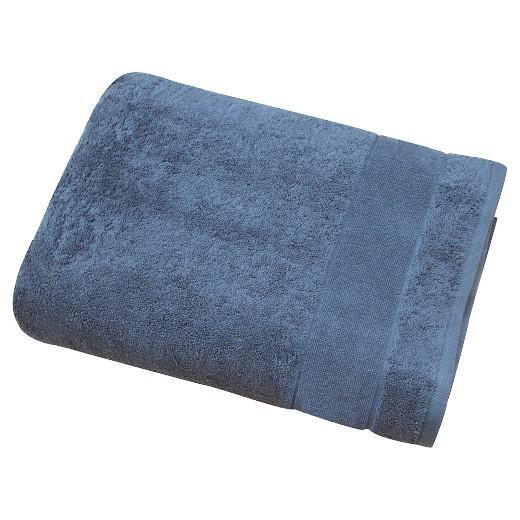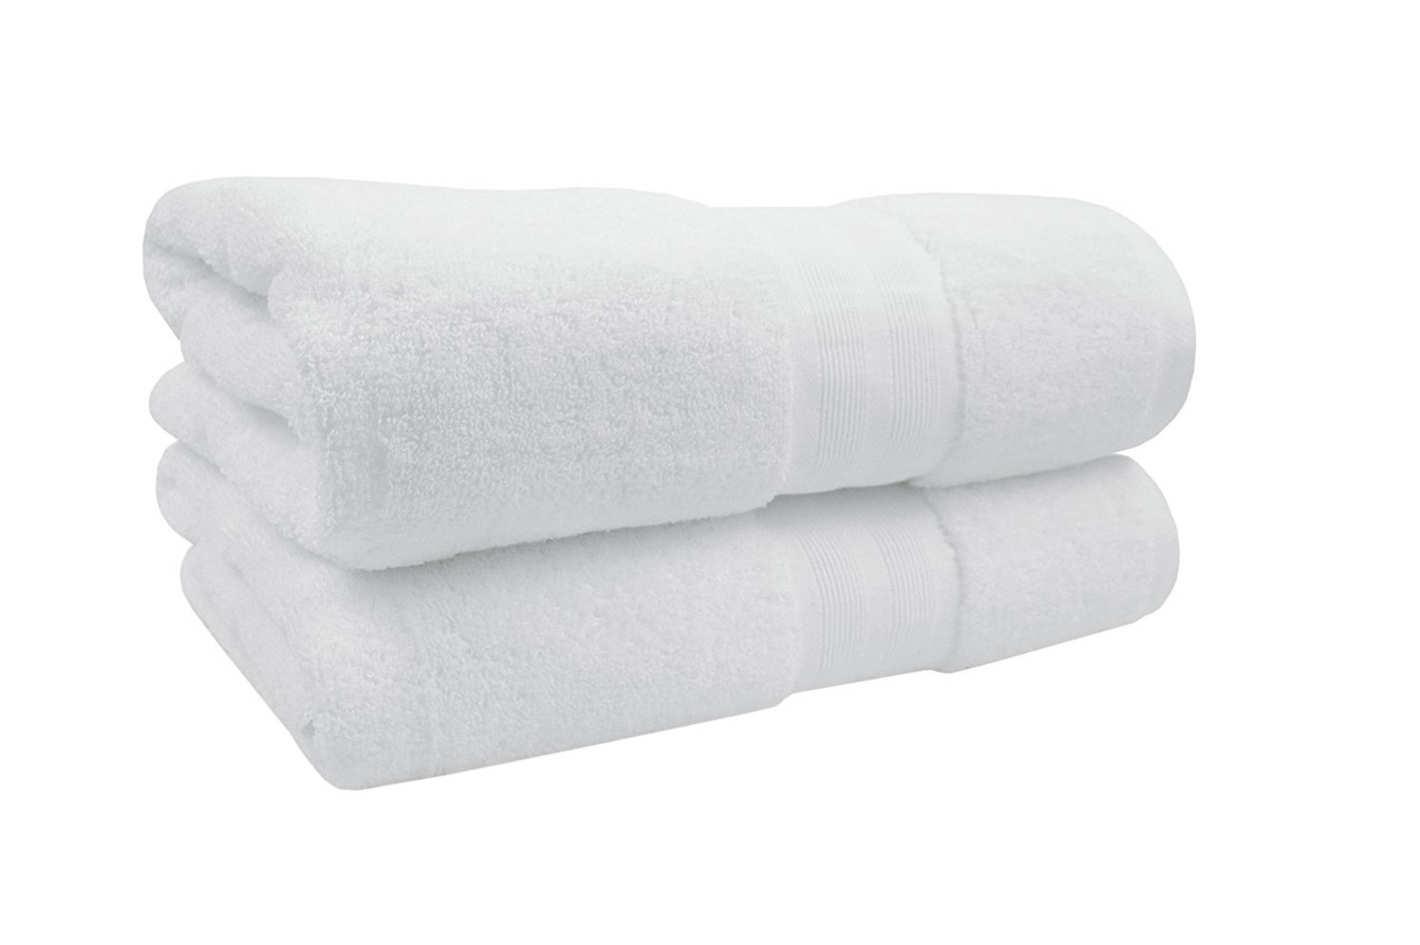The first image is the image on the left, the second image is the image on the right. Examine the images to the left and right. Is the description "Each image shows exactly two piles of multiple towels in different solid colors." accurate? Answer yes or no. No. 